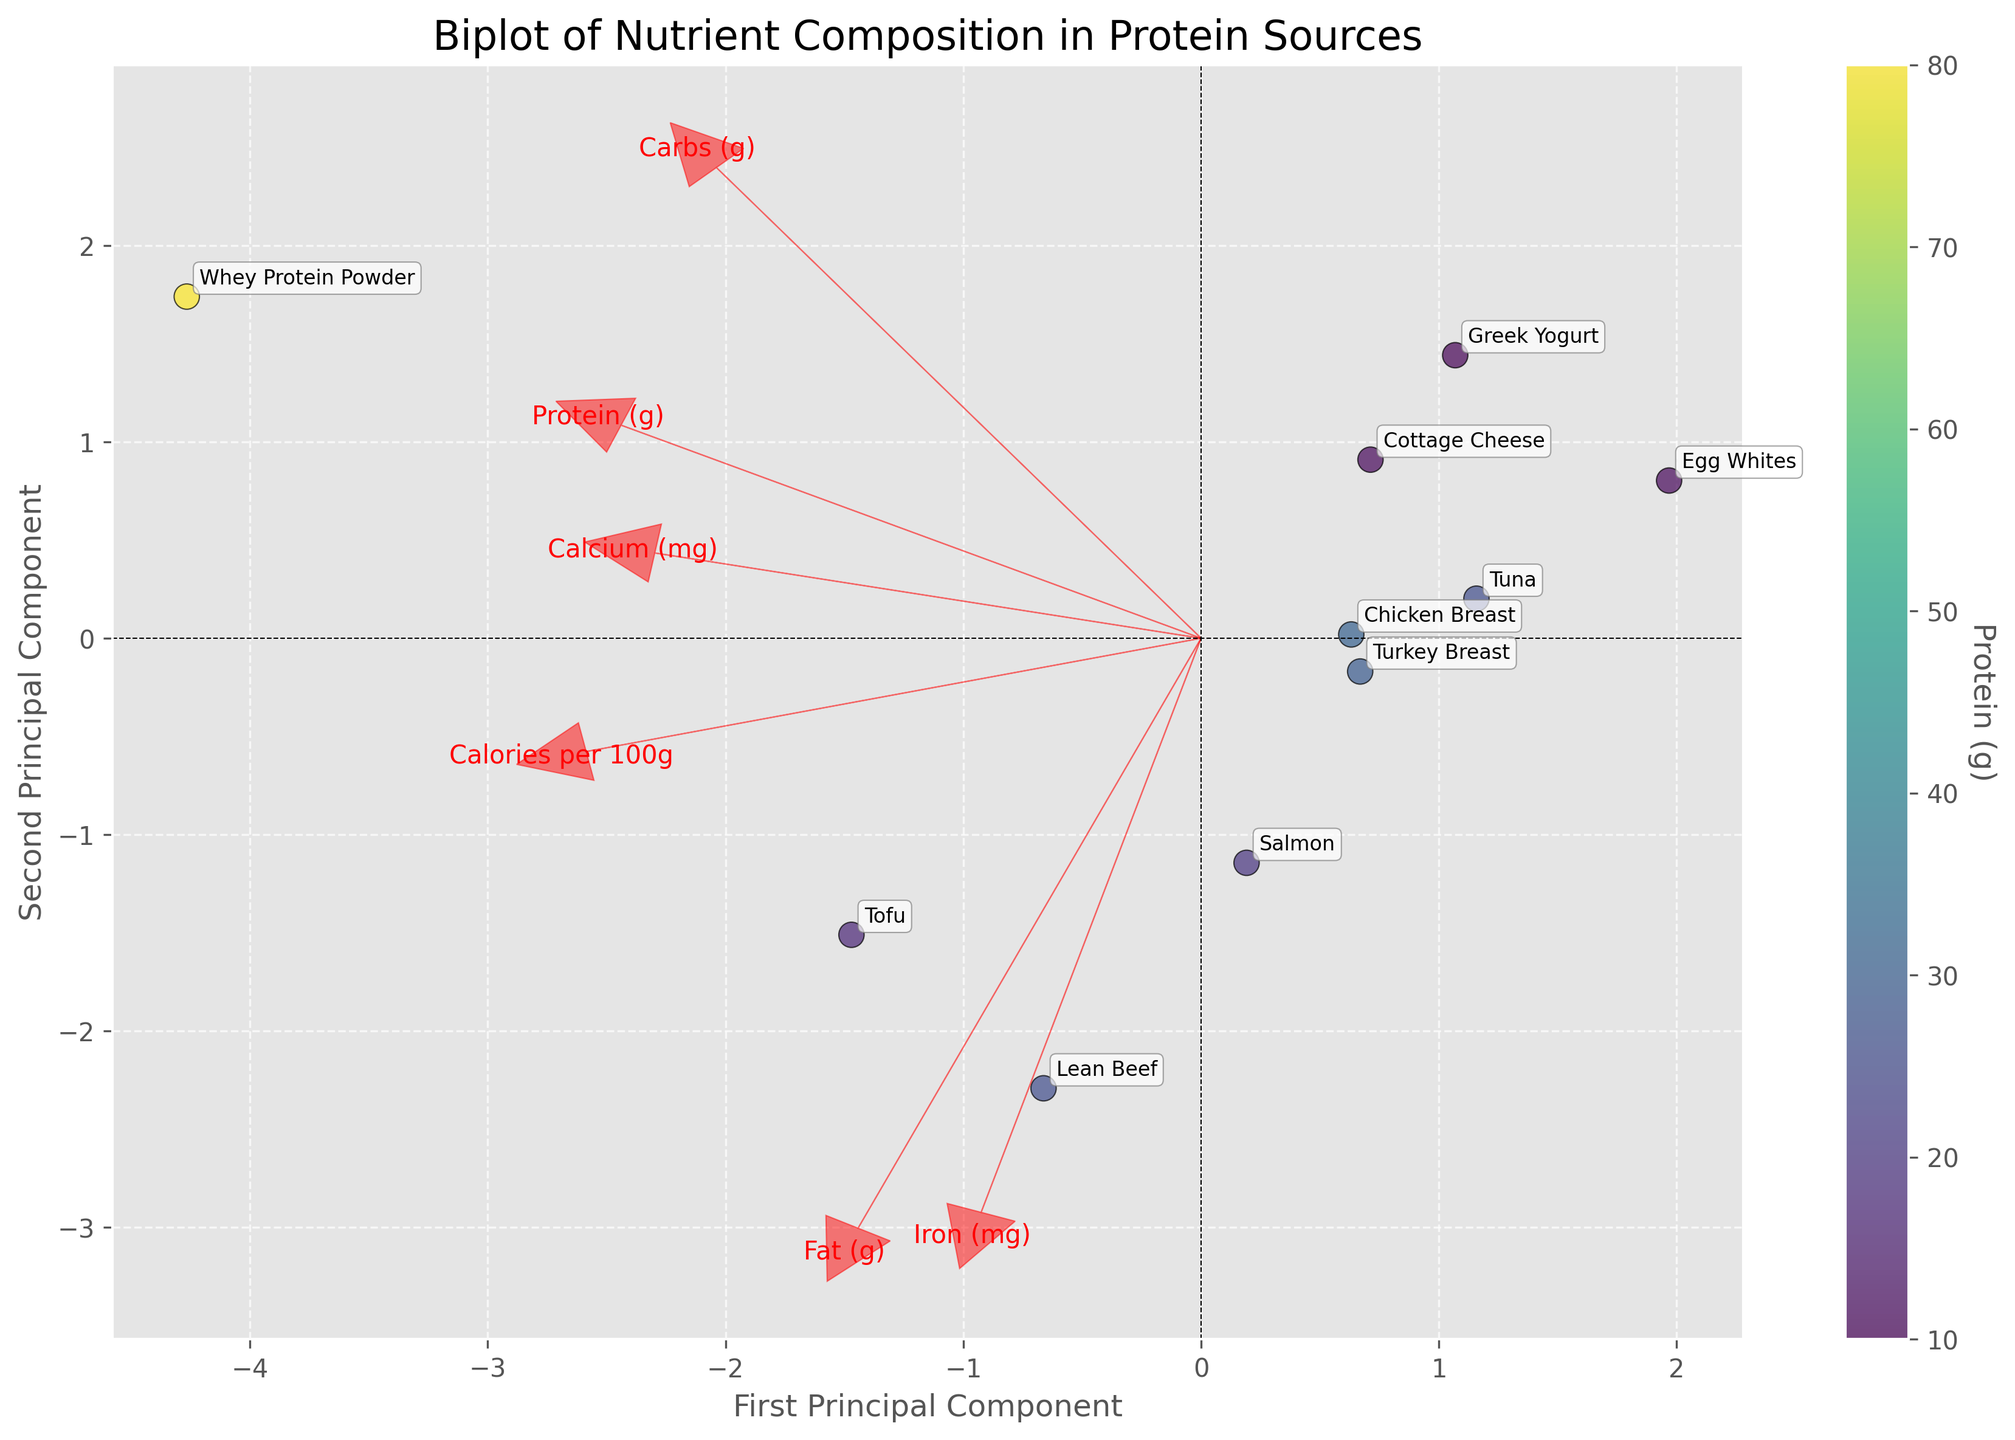How many protein sources are displayed in the plot? To find the number of protein sources, you can count all the data points (nodes) labeled with protein source names in the biplot.
Answer: 10 What is the label of the x-axis? The x-axis label is typically found along the horizontal axis of the plot. In this case, it is labeled "First Principal Component".
Answer: First Principal Component Which protein source appears to have the highest protein content? The color intensity of each point represents the protein content. The point with the darkest shade of color represents the highest protein content. This data point is associated with "Whey Protein Powder".
Answer: Whey Protein Powder How do calories per 100g and fat affect the first principal component? To understand the effect on the first principal component, observe the direction and length of the arrows representing "Calories per 100g" and "Fat (g)". Longer arrows pointing in the direction of the first principal component indicate a strong positive correlation.
Answer: Both have a positive effect Which nutrient has a negative effect on the second principal component? To determine this, look at the direction of the arrows. The arrow pointing in the opposite direction of the second principal component (vertical axis) represents a negative effect.
Answer: Iron (mg) Compare the positions of chicken breast and tofu protein sources in the plot. Which one is closer to the origin and what does that imply? To compare positions, note the proximity of both points to the origin (0,0). The closer a point is to the origin, the more average it is across all principal components. By observing the biplot, "Chicken Breast" is closer to the origin than "Tofu".
Answer: Chicken Breast is closer, implying it is more average in nutrient composition What does the length of the arrows represent in this biplot? The length of the arrows represents the magnitude of contribution of each nutrient to the principal components. Longer arrows imply a stronger influence of that nutrient on the data variation in those directions.
Answer: Magnitude of contribution Which protein source has the highest calcium content and how is it identified in the biplot? To identify this, find the protein source that aligns most closely with the direction of the "Calcium (mg)" arrow, and consider the labels on the data points. "Tofu" is closest to the arrow indicating high calcium content.
Answer: Tofu What can be inferred about the relationship between protein content and iron content based on the biplot? Analyze the direction and correlation of the arrows for "Protein (g)" and "Iron (mg)". If the arrows are close in direction, they are positively correlated; opposite directions indicate a negative correlation. Here, they are nearly perpendicular, indicating little to no correlation.
Answer: Little to no correlation Which nutrient appears to have the least impact on both principal components combined? The nutrient with the shortest arrow length indicates the least impact. By observing the plot, "Carbs (g)" has the shortest arrow, signifying the least impact.
Answer: Carbs (g) 